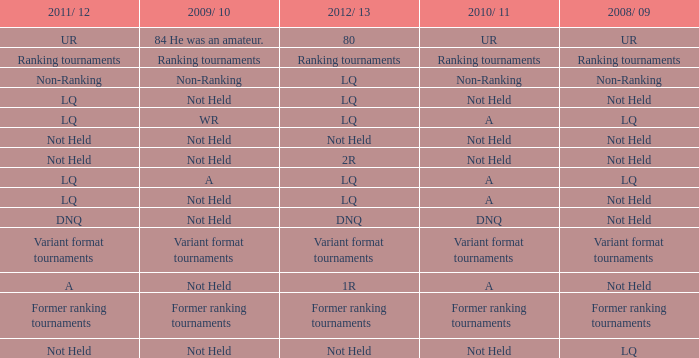When the 2008/ 09 has non-ranking what is the 2009/ 10? Non-Ranking. 